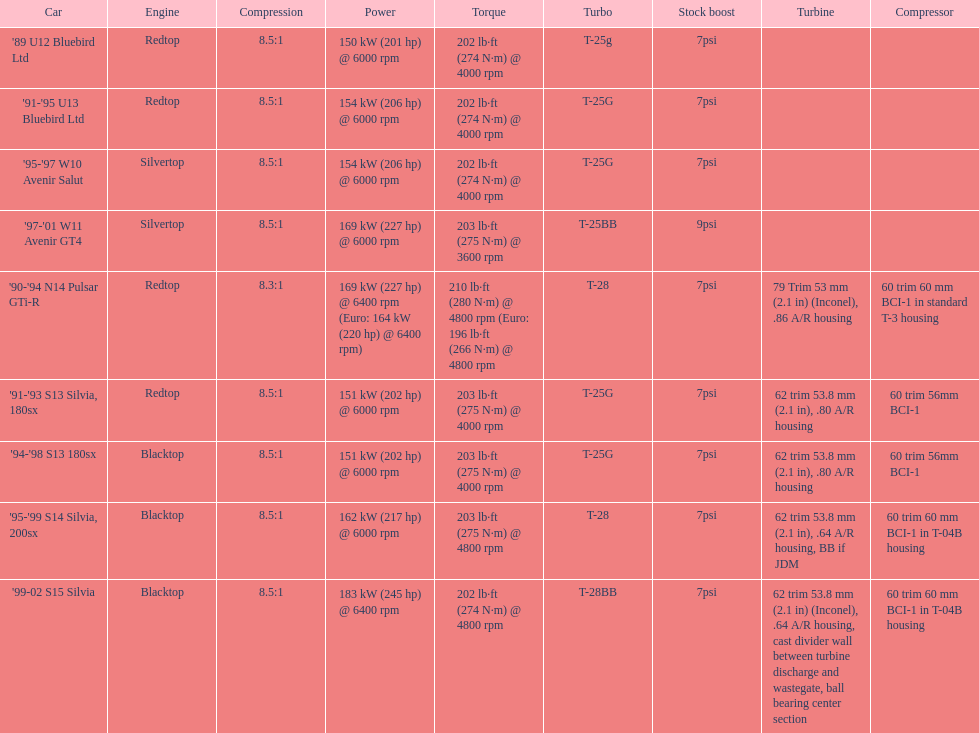Which vehicles include turbine specifications? '90-'94 N14 Pulsar GTi-R, '91-'93 S13 Silvia, 180sx, '94-'98 S13 180sx, '95-'99 S14 Silvia, 200sx, '99-02 S15 Silvia. Which one achieves its highest horsepower at the greatest rpm? '90-'94 N14 Pulsar GTi-R, '99-02 S15 Silvia. Additionally, what is the compression ratio of the only engine that isn't blacktop? 8.3:1. Can you give me this table as a dict? {'header': ['Car', 'Engine', 'Compression', 'Power', 'Torque', 'Turbo', 'Stock boost', 'Turbine', 'Compressor'], 'rows': [["'89 U12 Bluebird Ltd", 'Redtop', '8.5:1', '150\xa0kW (201\xa0hp) @ 6000 rpm', '202\xa0lb·ft (274\xa0N·m) @ 4000 rpm', 'T-25g', '7psi', '', ''], ["'91-'95 U13 Bluebird Ltd", 'Redtop', '8.5:1', '154\xa0kW (206\xa0hp) @ 6000 rpm', '202\xa0lb·ft (274\xa0N·m) @ 4000 rpm', 'T-25G', '7psi', '', ''], ["'95-'97 W10 Avenir Salut", 'Silvertop', '8.5:1', '154\xa0kW (206\xa0hp) @ 6000 rpm', '202\xa0lb·ft (274\xa0N·m) @ 4000 rpm', 'T-25G', '7psi', '', ''], ["'97-'01 W11 Avenir GT4", 'Silvertop', '8.5:1', '169\xa0kW (227\xa0hp) @ 6000 rpm', '203\xa0lb·ft (275\xa0N·m) @ 3600 rpm', 'T-25BB', '9psi', '', ''], ["'90-'94 N14 Pulsar GTi-R", 'Redtop', '8.3:1', '169\xa0kW (227\xa0hp) @ 6400 rpm (Euro: 164\xa0kW (220\xa0hp) @ 6400 rpm)', '210\xa0lb·ft (280\xa0N·m) @ 4800 rpm (Euro: 196\xa0lb·ft (266\xa0N·m) @ 4800 rpm', 'T-28', '7psi', '79 Trim 53\xa0mm (2.1\xa0in) (Inconel), .86 A/R housing', '60 trim 60\xa0mm BCI-1 in standard T-3 housing'], ["'91-'93 S13 Silvia, 180sx", 'Redtop', '8.5:1', '151\xa0kW (202\xa0hp) @ 6000 rpm', '203\xa0lb·ft (275\xa0N·m) @ 4000 rpm', 'T-25G', '7psi', '62 trim 53.8\xa0mm (2.1\xa0in), .80 A/R housing', '60 trim 56mm BCI-1'], ["'94-'98 S13 180sx", 'Blacktop', '8.5:1', '151\xa0kW (202\xa0hp) @ 6000 rpm', '203\xa0lb·ft (275\xa0N·m) @ 4000 rpm', 'T-25G', '7psi', '62 trim 53.8\xa0mm (2.1\xa0in), .80 A/R housing', '60 trim 56mm BCI-1'], ["'95-'99 S14 Silvia, 200sx", 'Blacktop', '8.5:1', '162\xa0kW (217\xa0hp) @ 6000 rpm', '203\xa0lb·ft (275\xa0N·m) @ 4800 rpm', 'T-28', '7psi', '62 trim 53.8\xa0mm (2.1\xa0in), .64 A/R housing, BB if JDM', '60 trim 60\xa0mm BCI-1 in T-04B housing'], ["'99-02 S15 Silvia", 'Blacktop', '8.5:1', '183\xa0kW (245\xa0hp) @ 6400 rpm', '202\xa0lb·ft (274\xa0N·m) @ 4800 rpm', 'T-28BB', '7psi', '62 trim 53.8\xa0mm (2.1\xa0in) (Inconel), .64 A/R housing, cast divider wall between turbine discharge and wastegate, ball bearing center section', '60 trim 60\xa0mm BCI-1 in T-04B housing']]} 